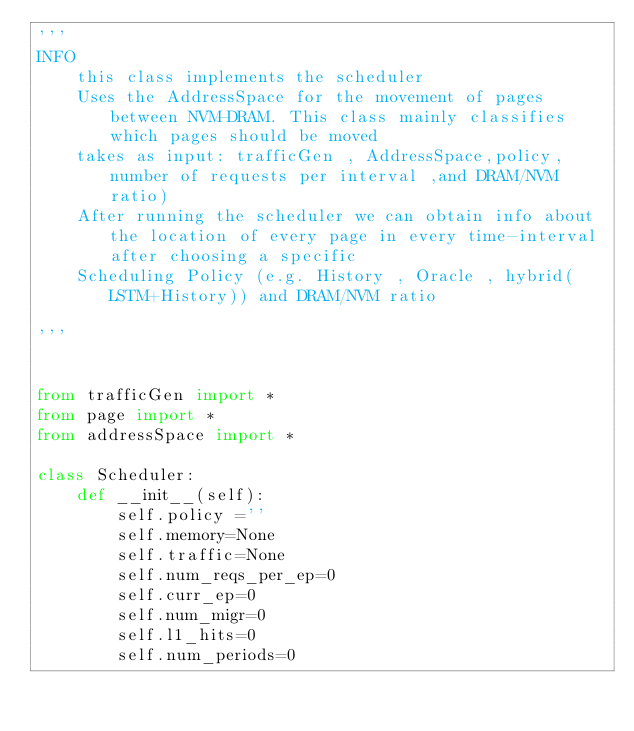<code> <loc_0><loc_0><loc_500><loc_500><_Python_>'''
INFO
    this class implements the scheduler 
    Uses the AddressSpace for the movement of pages between NVM-DRAM. This class mainly classifies which pages should be moved
    takes as input: trafficGen , AddressSpace,policy, number of requests per interval ,and DRAM/NVM ratio)
    After running the scheduler we can obtain info about the location of every page in every time-interval after choosing a specific 
    Scheduling Policy (e.g. History , Oracle , hybrid(LSTM+History)) and DRAM/NVM ratio

'''


from trafficGen import *
from page import *
from addressSpace import *

class Scheduler:
    def __init__(self):
        self.policy =''
        self.memory=None
        self.traffic=None
        self.num_reqs_per_ep=0
        self.curr_ep=0
        self.num_migr=0
        self.l1_hits=0
        self.num_periods=0
        </code> 